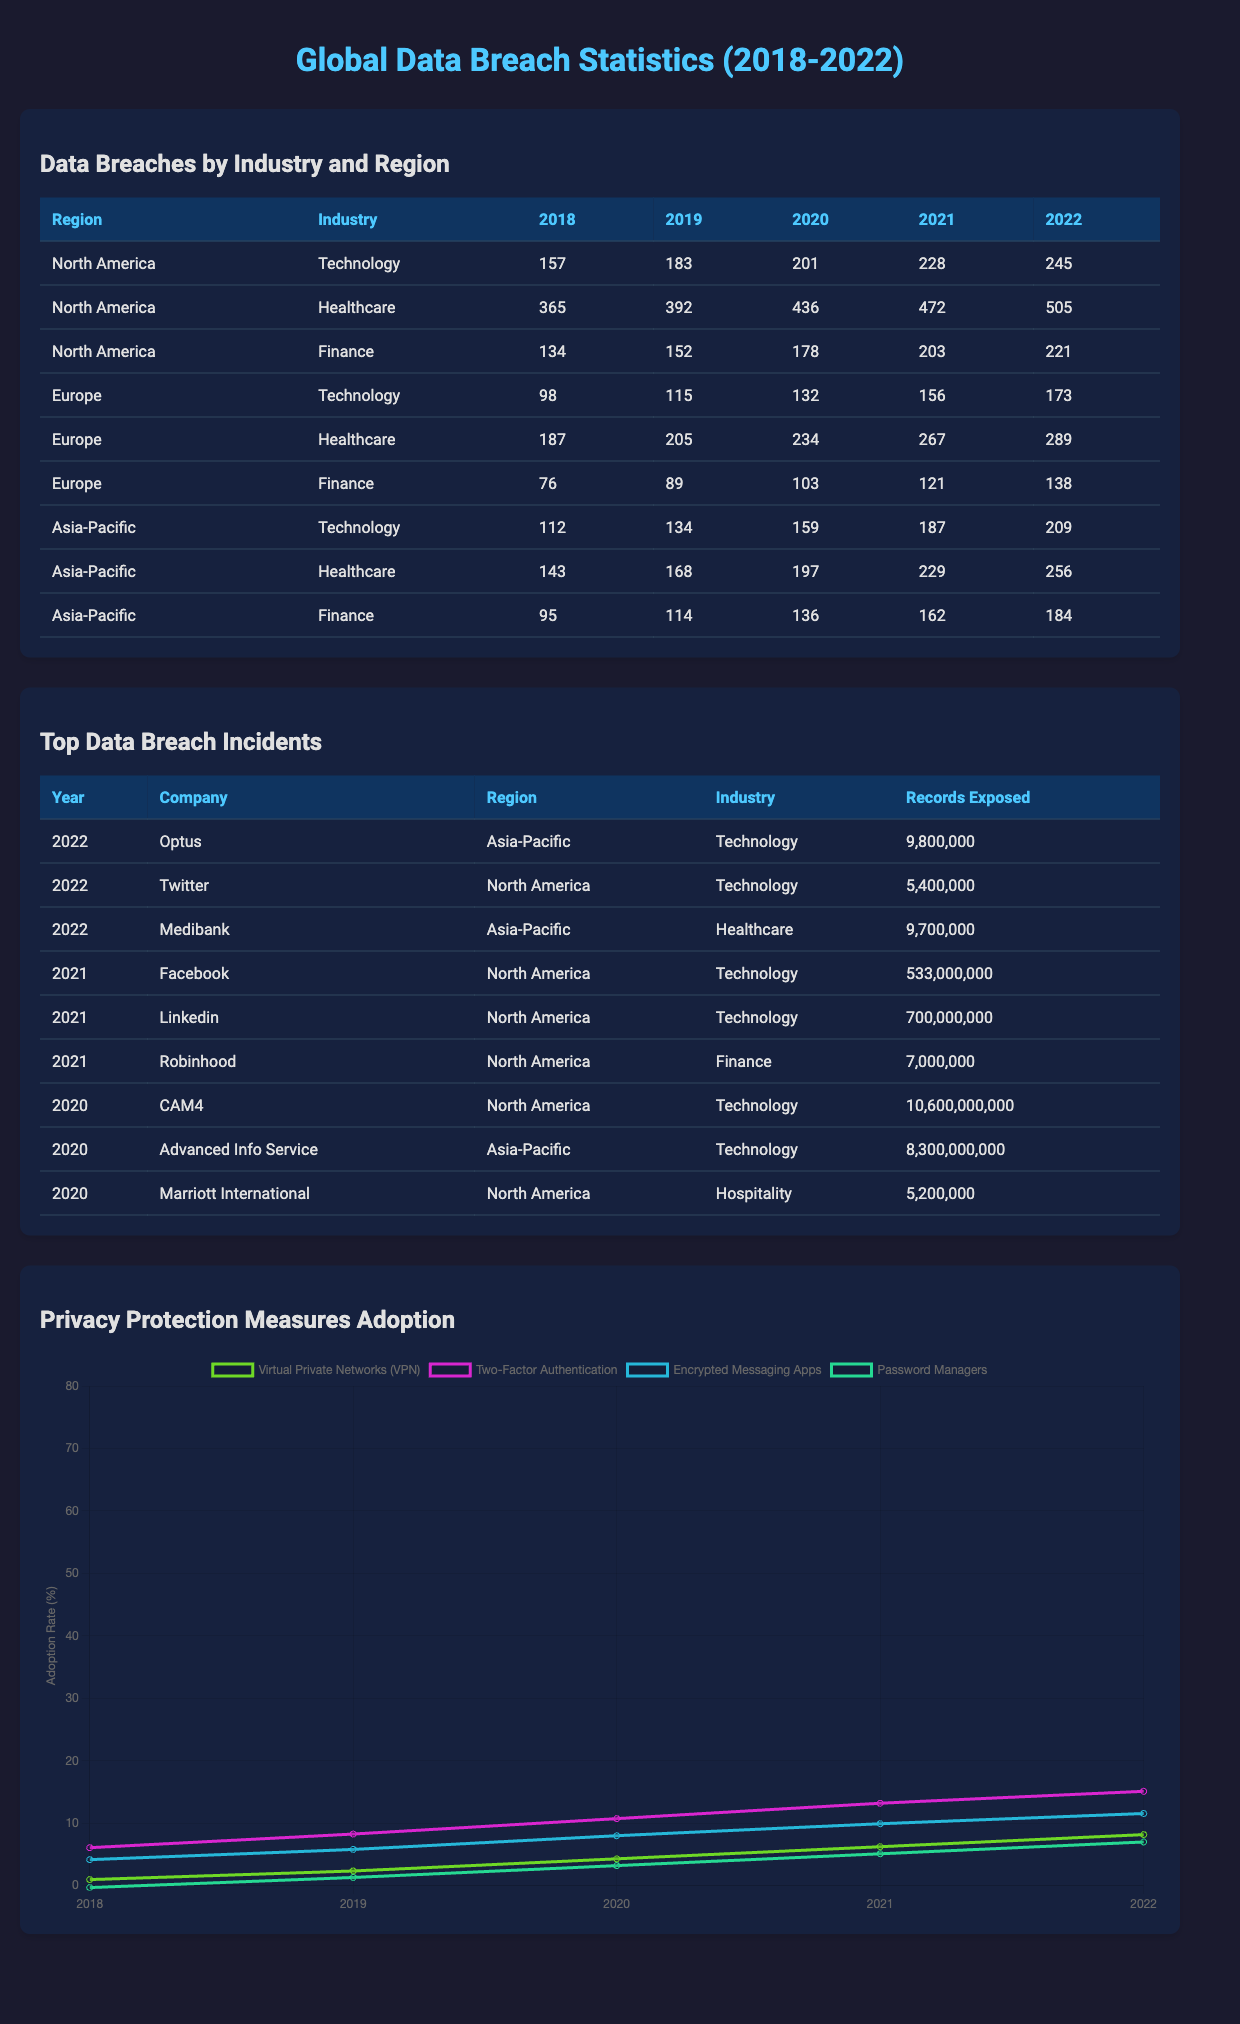What was the highest number of data breaches recorded in the Healthcare industry in North America over the five years? The highest number of data breaches recorded in the Healthcare industry in North America is 505 in 2022.
Answer: 505 What was the trend in data breaches for the Finance industry in Europe from 2018 to 2022? The number of data breaches in the Finance industry in Europe increased from 76 in 2018 to 138 in 2022, showing a consistent upward trend each year.
Answer: Increasing How many more data breaches occurred in the Technology industry in North America than in Europe in 2022? In North America, there were 245 data breaches in the Technology industry, while in Europe, there were 173 in the same year. The difference is 245 - 173 = 72.
Answer: 72 What is the total number of data breaches across all industries in Asia-Pacific for the year 2021? The total number of data breaches in Asia-Pacific for 2021 is calculated as follows: Technology (187) + Healthcare (229) + Finance (162) = 578.
Answer: 578 In which year did the Financial industry in North America experience the least data breaches? In North America, the Finance industry had the least data breaches in 2018, with a total of 134 breaches.
Answer: 2018 Did the number of data breaches in the Healthcare industry increase every year in North America? Yes, the data shows that the number of breaches in the Healthcare industry increased every year from 2018 to 2022, starting from 365 and reaching 505 in 2022.
Answer: Yes What was the total number of records exposed by the top three data breach incidents in 2022? The total for 2022 is calculated by summing up the records exposed: Optus (9,800,000) + Twitter (5,400,000) + Medibank (9,700,000), leading to a total of 24,900,000 records exposed.
Answer: 24,900,000 Which region had the highest recorded data breaches in the Technology industry in 2020? In 2020, North America had the highest recorded data breaches in the Technology industry with a total of 201 breaches.
Answer: North America What percentage increase in data breaches occurred in the Healthcare industry in Europe from 2018 to 2022? The increase from 187 in 2018 to 289 in 2022 calculates as follows: (289 - 187) / 187 * 100 = 54.5%.
Answer: 54.5% Which industry saw the lowest number of recorded breaches in Europe in 2021? In Europe in 2021, the Finance industry had the lowest number of recorded breaches with a total of 121 breaches.
Answer: Finance 